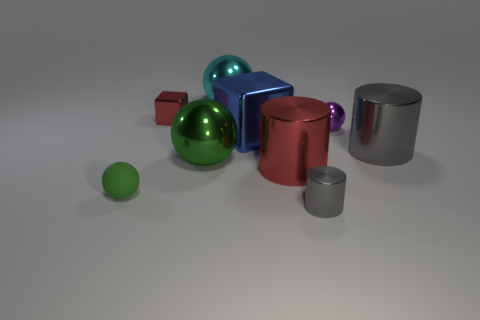How many tiny things are either purple cubes or red objects?
Give a very brief answer. 1. What color is the large ball that is made of the same material as the cyan thing?
Keep it short and to the point. Green. Do the green thing behind the tiny green sphere and the green object that is in front of the red cylinder have the same shape?
Keep it short and to the point. Yes. How many metallic things are big gray objects or big red cylinders?
Offer a very short reply. 2. There is another big thing that is the same color as the matte object; what is it made of?
Provide a succinct answer. Metal. What is the material of the green sphere in front of the big red thing?
Keep it short and to the point. Rubber. Do the ball on the right side of the large cube and the red cube have the same material?
Offer a terse response. Yes. What number of things are small purple shiny objects or spheres in front of the tiny purple object?
Ensure brevity in your answer.  3. There is a cyan object that is the same shape as the tiny purple object; what is its size?
Offer a very short reply. Large. Are there any balls in front of the green metal ball?
Ensure brevity in your answer.  Yes. 